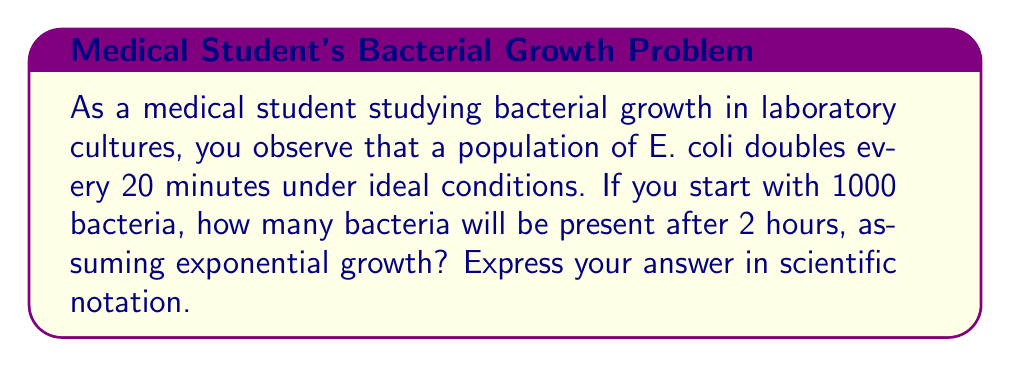Teach me how to tackle this problem. To solve this problem, we need to use the exponential growth formula and determine the number of doubling periods that occur in 2 hours.

1. The exponential growth formula is:
   $$ N(t) = N_0 \cdot 2^{t/d} $$
   where:
   $N(t)$ is the number of bacteria at time $t$
   $N_0$ is the initial number of bacteria
   $t$ is the time elapsed
   $d$ is the doubling time

2. We are given:
   $N_0 = 1000$ bacteria
   $d = 20$ minutes
   $t = 2$ hours = 120 minutes

3. Calculate the number of doubling periods in 2 hours:
   $$ \text{Number of doubling periods} = \frac{120 \text{ minutes}}{20 \text{ minutes/doubling}} = 6 \text{ doublings} $$

4. Now we can apply the exponential growth formula:
   $$ N(120) = 1000 \cdot 2^6 $$

5. Calculate $2^6$:
   $$ 2^6 = 64 $$

6. Multiply:
   $$ N(120) = 1000 \cdot 64 = 64,000 $$

7. Express the result in scientific notation:
   $$ 64,000 = 6.4 \times 10^4 $$
Answer: $6.4 \times 10^4$ bacteria 